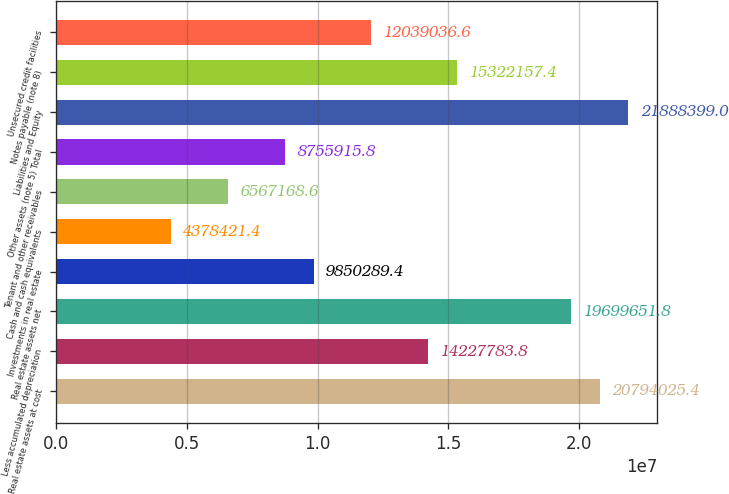Convert chart to OTSL. <chart><loc_0><loc_0><loc_500><loc_500><bar_chart><fcel>Real estate assets at cost<fcel>Less accumulated depreciation<fcel>Real estate assets net<fcel>Investments in real estate<fcel>Cash and cash equivalents<fcel>Tenant and other receivables<fcel>Other assets (note 5) Total<fcel>Liabilities and Equity<fcel>Notes payable (note 8)<fcel>Unsecured credit facilities<nl><fcel>2.0794e+07<fcel>1.42278e+07<fcel>1.96997e+07<fcel>9.85029e+06<fcel>4.37842e+06<fcel>6.56717e+06<fcel>8.75592e+06<fcel>2.18884e+07<fcel>1.53222e+07<fcel>1.2039e+07<nl></chart> 